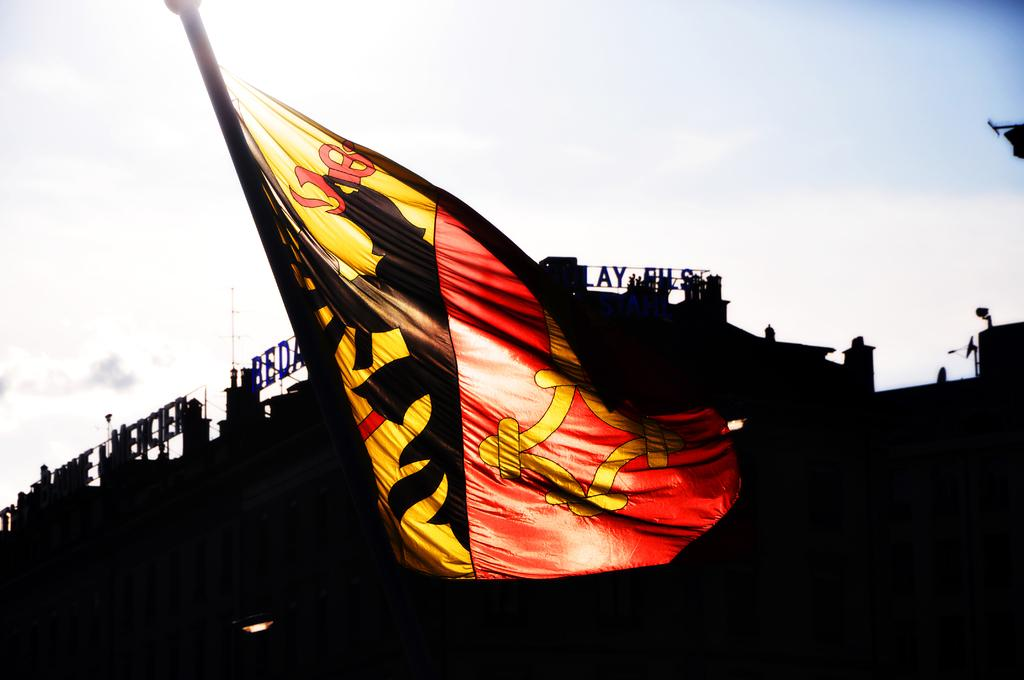What can be seen in the image that represents a symbol or country? There is a flag in the image that represents a symbol or country. How many colors are present on the flag? The flag has two different colors. What is visible in the background of the image? The sky is visible in the image. How would you describe the weather based on the appearance of the sky? The sky appears clear, which suggests good weather. What is located behind the flag in the image? There is a hoarding behind the flag. Can you describe what is written on the hoarding? The hoarding has some alphabets written on it. How many cows are visible in the image? There are no cows present in the image. What type of vessel is being used to transport the flag in the image? There is no vessel present in the image, and the flag is not being transported. 